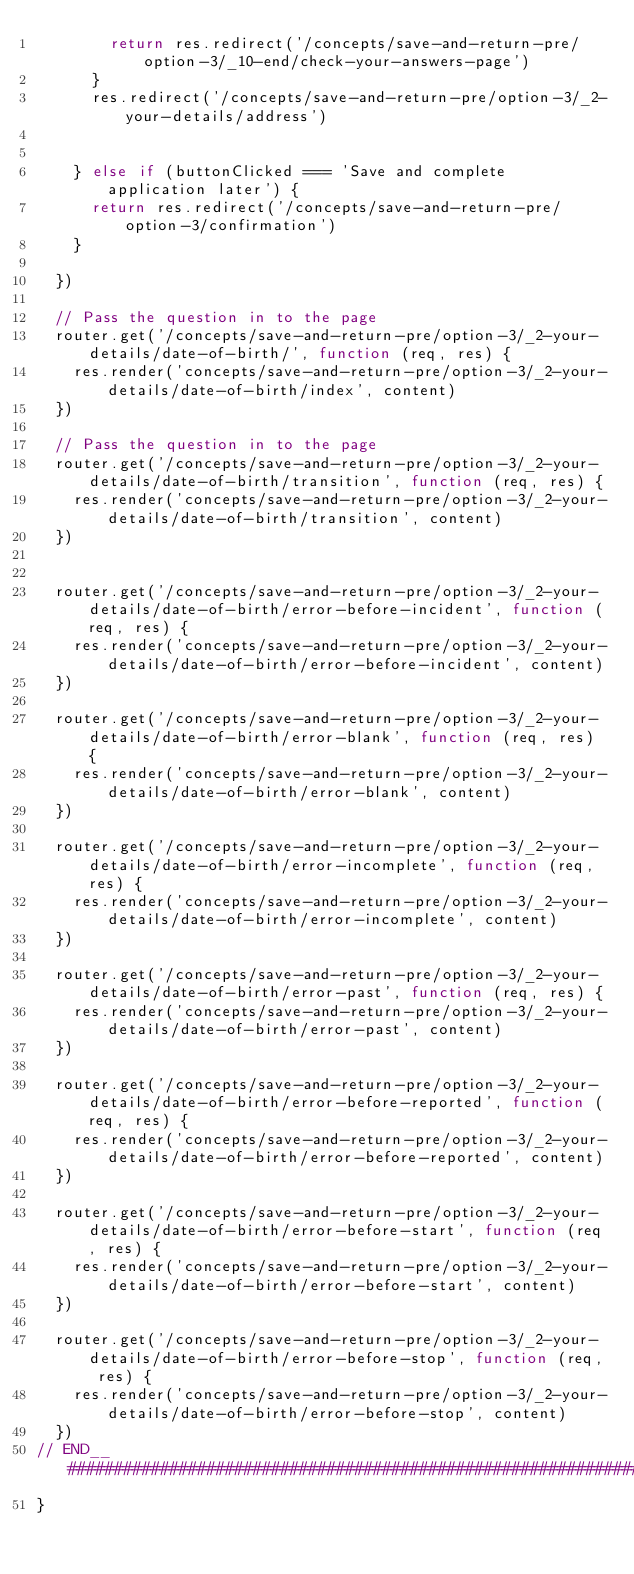<code> <loc_0><loc_0><loc_500><loc_500><_JavaScript_>        return res.redirect('/concepts/save-and-return-pre/option-3/_10-end/check-your-answers-page')
      }
      res.redirect('/concepts/save-and-return-pre/option-3/_2-your-details/address')


    } else if (buttonClicked === 'Save and complete application later') {
      return res.redirect('/concepts/save-and-return-pre/option-3/confirmation')
    }

  })

  // Pass the question in to the page
  router.get('/concepts/save-and-return-pre/option-3/_2-your-details/date-of-birth/', function (req, res) {
    res.render('concepts/save-and-return-pre/option-3/_2-your-details/date-of-birth/index', content)
  })

  // Pass the question in to the page
  router.get('/concepts/save-and-return-pre/option-3/_2-your-details/date-of-birth/transition', function (req, res) {
    res.render('concepts/save-and-return-pre/option-3/_2-your-details/date-of-birth/transition', content)
  })


  router.get('/concepts/save-and-return-pre/option-3/_2-your-details/date-of-birth/error-before-incident', function (req, res) {
    res.render('concepts/save-and-return-pre/option-3/_2-your-details/date-of-birth/error-before-incident', content)
  })

  router.get('/concepts/save-and-return-pre/option-3/_2-your-details/date-of-birth/error-blank', function (req, res) {
    res.render('concepts/save-and-return-pre/option-3/_2-your-details/date-of-birth/error-blank', content)
  })

  router.get('/concepts/save-and-return-pre/option-3/_2-your-details/date-of-birth/error-incomplete', function (req, res) {
    res.render('concepts/save-and-return-pre/option-3/_2-your-details/date-of-birth/error-incomplete', content)
  })

  router.get('/concepts/save-and-return-pre/option-3/_2-your-details/date-of-birth/error-past', function (req, res) {
    res.render('concepts/save-and-return-pre/option-3/_2-your-details/date-of-birth/error-past', content)
  })

  router.get('/concepts/save-and-return-pre/option-3/_2-your-details/date-of-birth/error-before-reported', function (req, res) {
    res.render('concepts/save-and-return-pre/option-3/_2-your-details/date-of-birth/error-before-reported', content)
  })

  router.get('/concepts/save-and-return-pre/option-3/_2-your-details/date-of-birth/error-before-start', function (req, res) {
    res.render('concepts/save-and-return-pre/option-3/_2-your-details/date-of-birth/error-before-start', content)
  })

  router.get('/concepts/save-and-return-pre/option-3/_2-your-details/date-of-birth/error-before-stop', function (req, res) {
    res.render('concepts/save-and-return-pre/option-3/_2-your-details/date-of-birth/error-before-stop', content)
  })
// END__######################################################################################################
}
</code> 